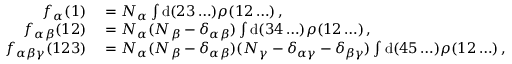<formula> <loc_0><loc_0><loc_500><loc_500>\begin{array} { r l } { f _ { \alpha } ( 1 ) } & = N _ { \alpha } \int d ( 2 3 \dots ) \rho ( 1 2 \dots ) \, , } \\ { f _ { \alpha \beta } ( 1 2 ) } & = N _ { \alpha } ( N _ { \beta } - \delta _ { \alpha \beta } ) \int d ( 3 4 \dots ) \rho ( 1 2 \dots ) \, , } \\ { f _ { \alpha \beta \gamma } ( 1 2 3 ) } & = N _ { \alpha } ( N _ { \beta } - \delta _ { \alpha \beta } ) ( N _ { \gamma } - \delta _ { \alpha \gamma } - \delta _ { \beta \gamma } ) \int d ( 4 5 \dots ) \rho ( 1 2 \dots ) \, , } \end{array}</formula> 